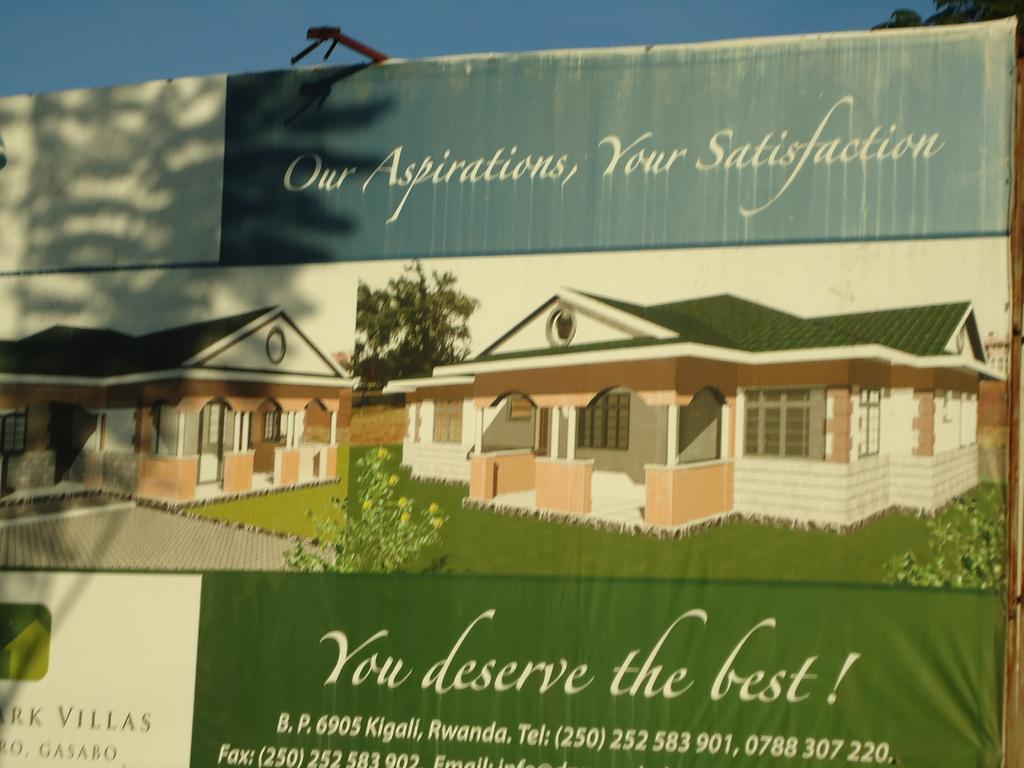What is the main object in the image? There is a board in the image. What is on the board? There is a banner on the board. What else can be seen in the image besides the board? There is a building and the sky visible in the image. Can you describe the building? There is text on the building. How do the planes react to the banner on the board in the image? There are no planes present in the image, so it is not possible to determine how they would react to the banner. 